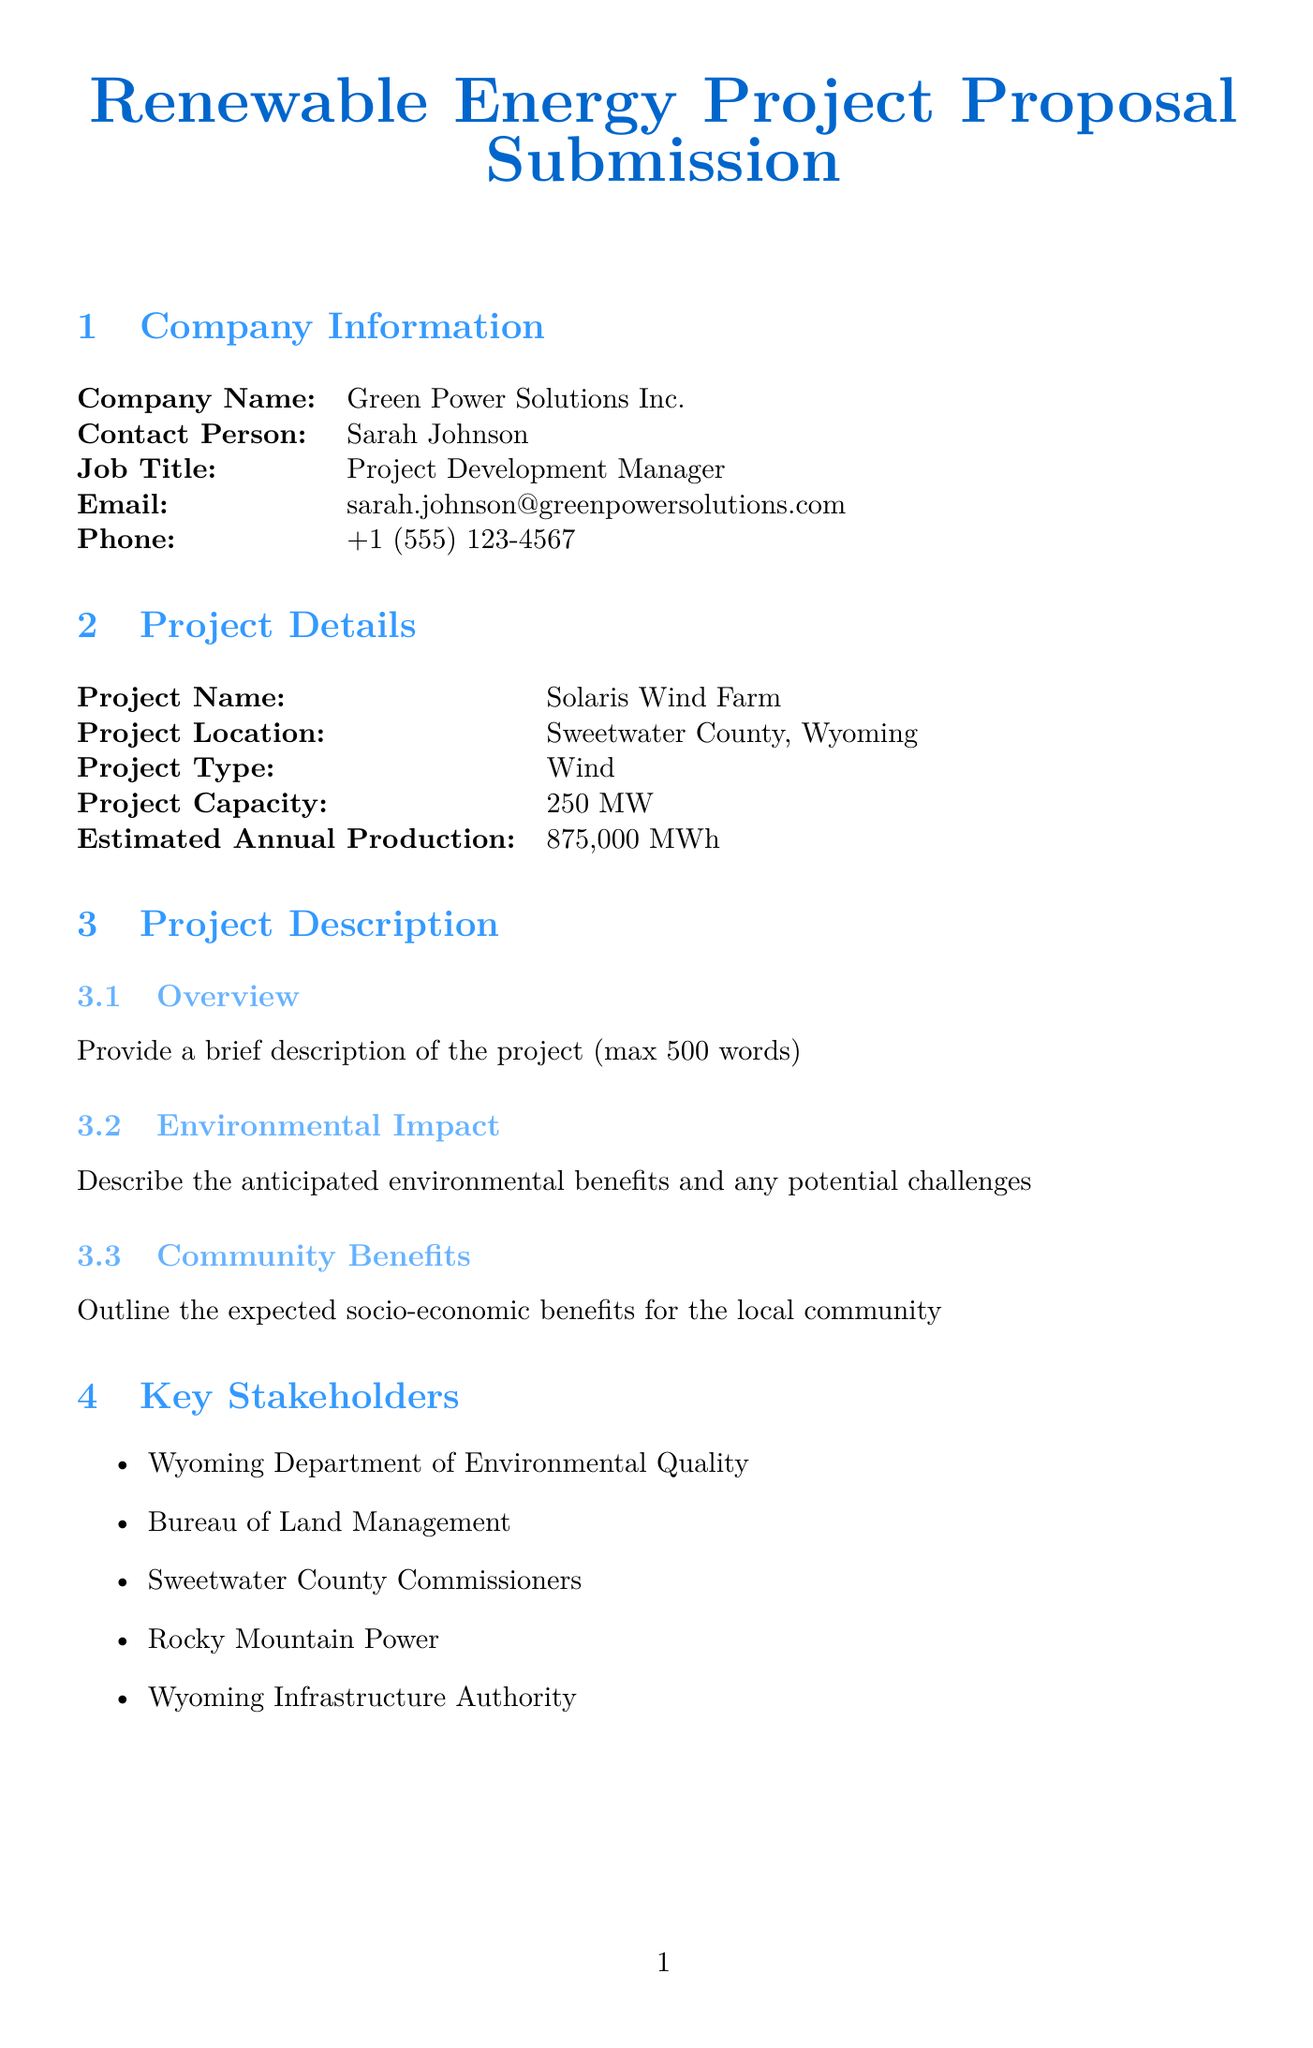what is the company name? The company name is listed in the document under Company Information.
Answer: Green Power Solutions Inc who is the contact person for the project? The contact person is mentioned in the Company Information section.
Answer: Sarah Johnson what is the estimated annual production of the project? The estimated annual production is specified in the Project Details section.
Answer: 875,000 MWh when does the construction phase start? The start date for the Construction phase is found in the Timeline section.
Answer: 2025-01-01 what is the total project cost? The total project cost is provided in the Budget Breakdown section.
Answer: 512,500,000 how many types of projects are mentioned? The number of project types is listed in the Project Details.
Answer: 5 who is the off-taker for the Power Purchase Agreement? The off-taker is identified in the Power Purchase Agreement section.
Answer: Rocky Mountain Power what is the contract duration for the Power Purchase Agreement? The contract duration is specified under the Power Purchase Agreement section.
Answer: 20 years what are the expected socio-economic benefits outlined in the project? The expected socio-economic benefits are discussed in the Community Benefits subsection.
Answer: (Requires a detailed response) 